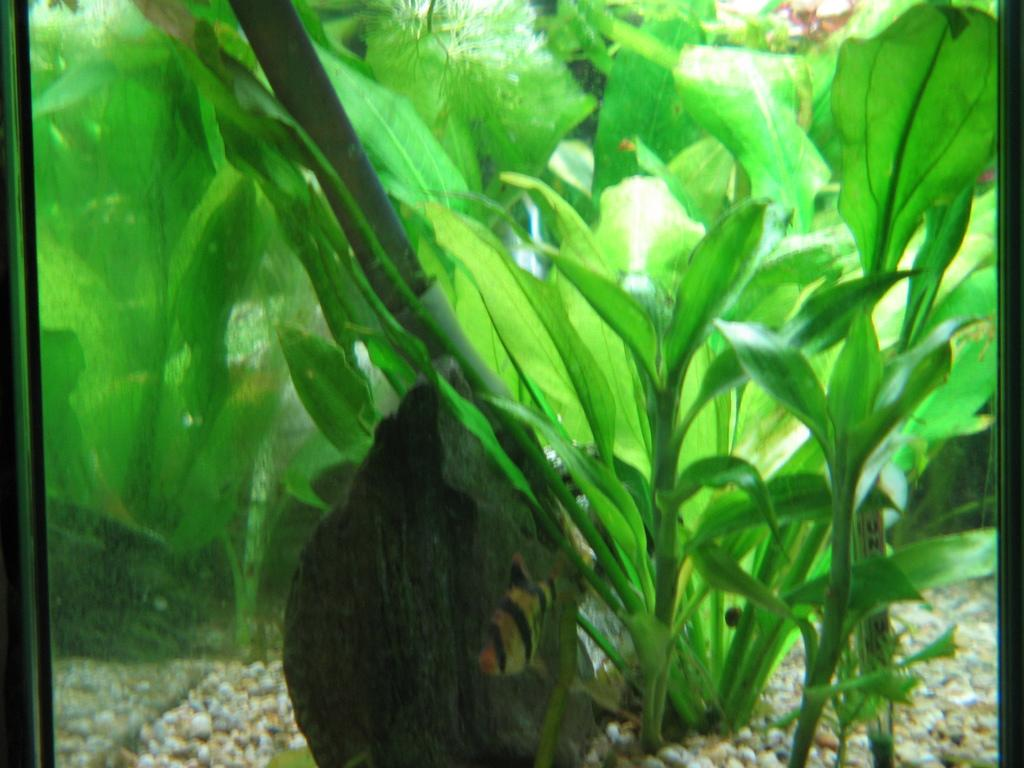What is the main subject of the image? The main subject of the image is an aquarium. Where is the aquarium located in the image? The aquarium is in the center of the image. What can be found inside the aquarium? There are stones and plants inside the aquarium. What type of cap can be seen floating in the aquarium? There is no cap present in the aquarium; it contains only stones and plants. Is there any blood visible in the image? There is no blood visible in the image; it features an aquarium with stones and plants. 